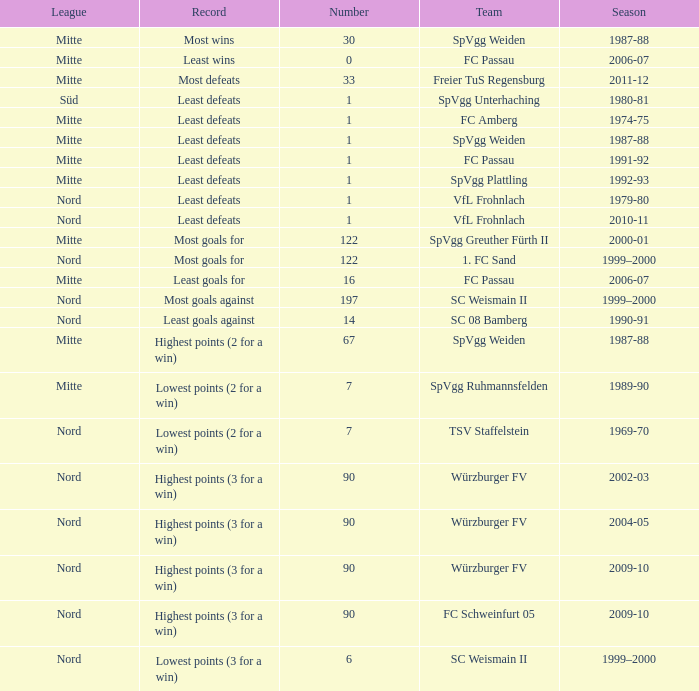What season has a number less than 90, Mitte as the league and spvgg ruhmannsfelden as the team? 1989-90. 